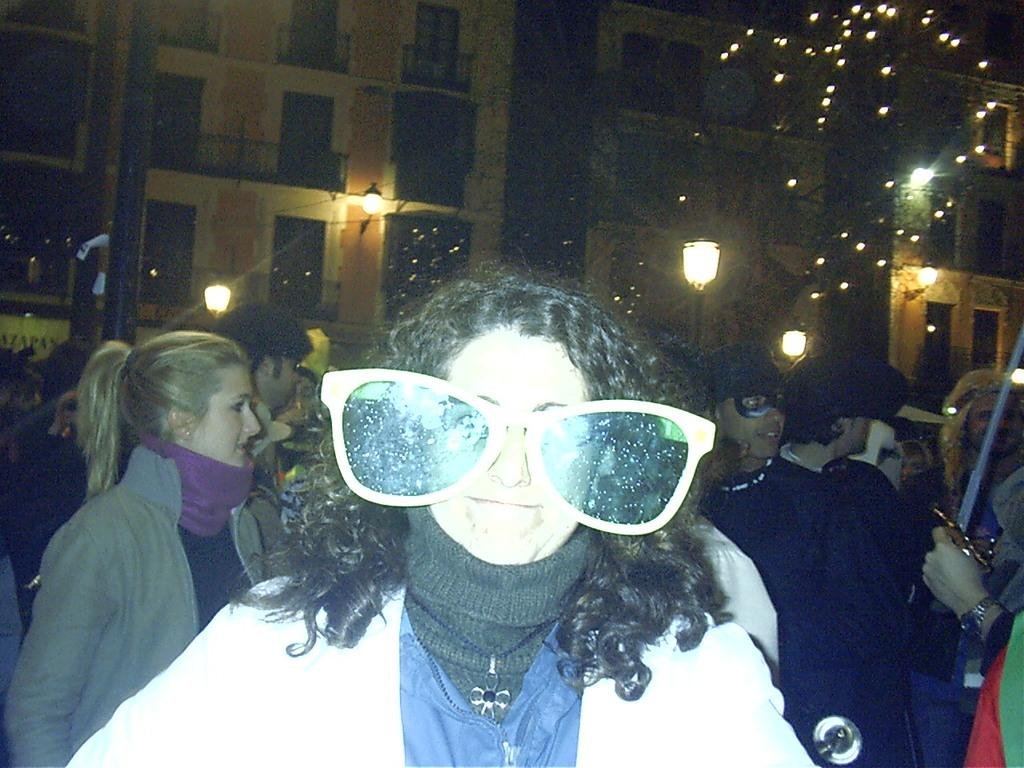How many people are in the image? There is a group of people in the image, but the exact number cannot be determined from the provided facts. What can be seen illuminating the scene in the image? There are lights in the image. What is the tall, vertical object in the image? There is a pole in the image. What type of structures are visible in the distance? There are buildings in the background of the image. What objects are present in the image that are not mentioned in the facts? The provided facts only mention lights, a pole, and buildings in the background. Any other objects cannot be confirmed. What type of cakes are being served to the people in the image? There is no mention of cakes in the image or the provided facts. 